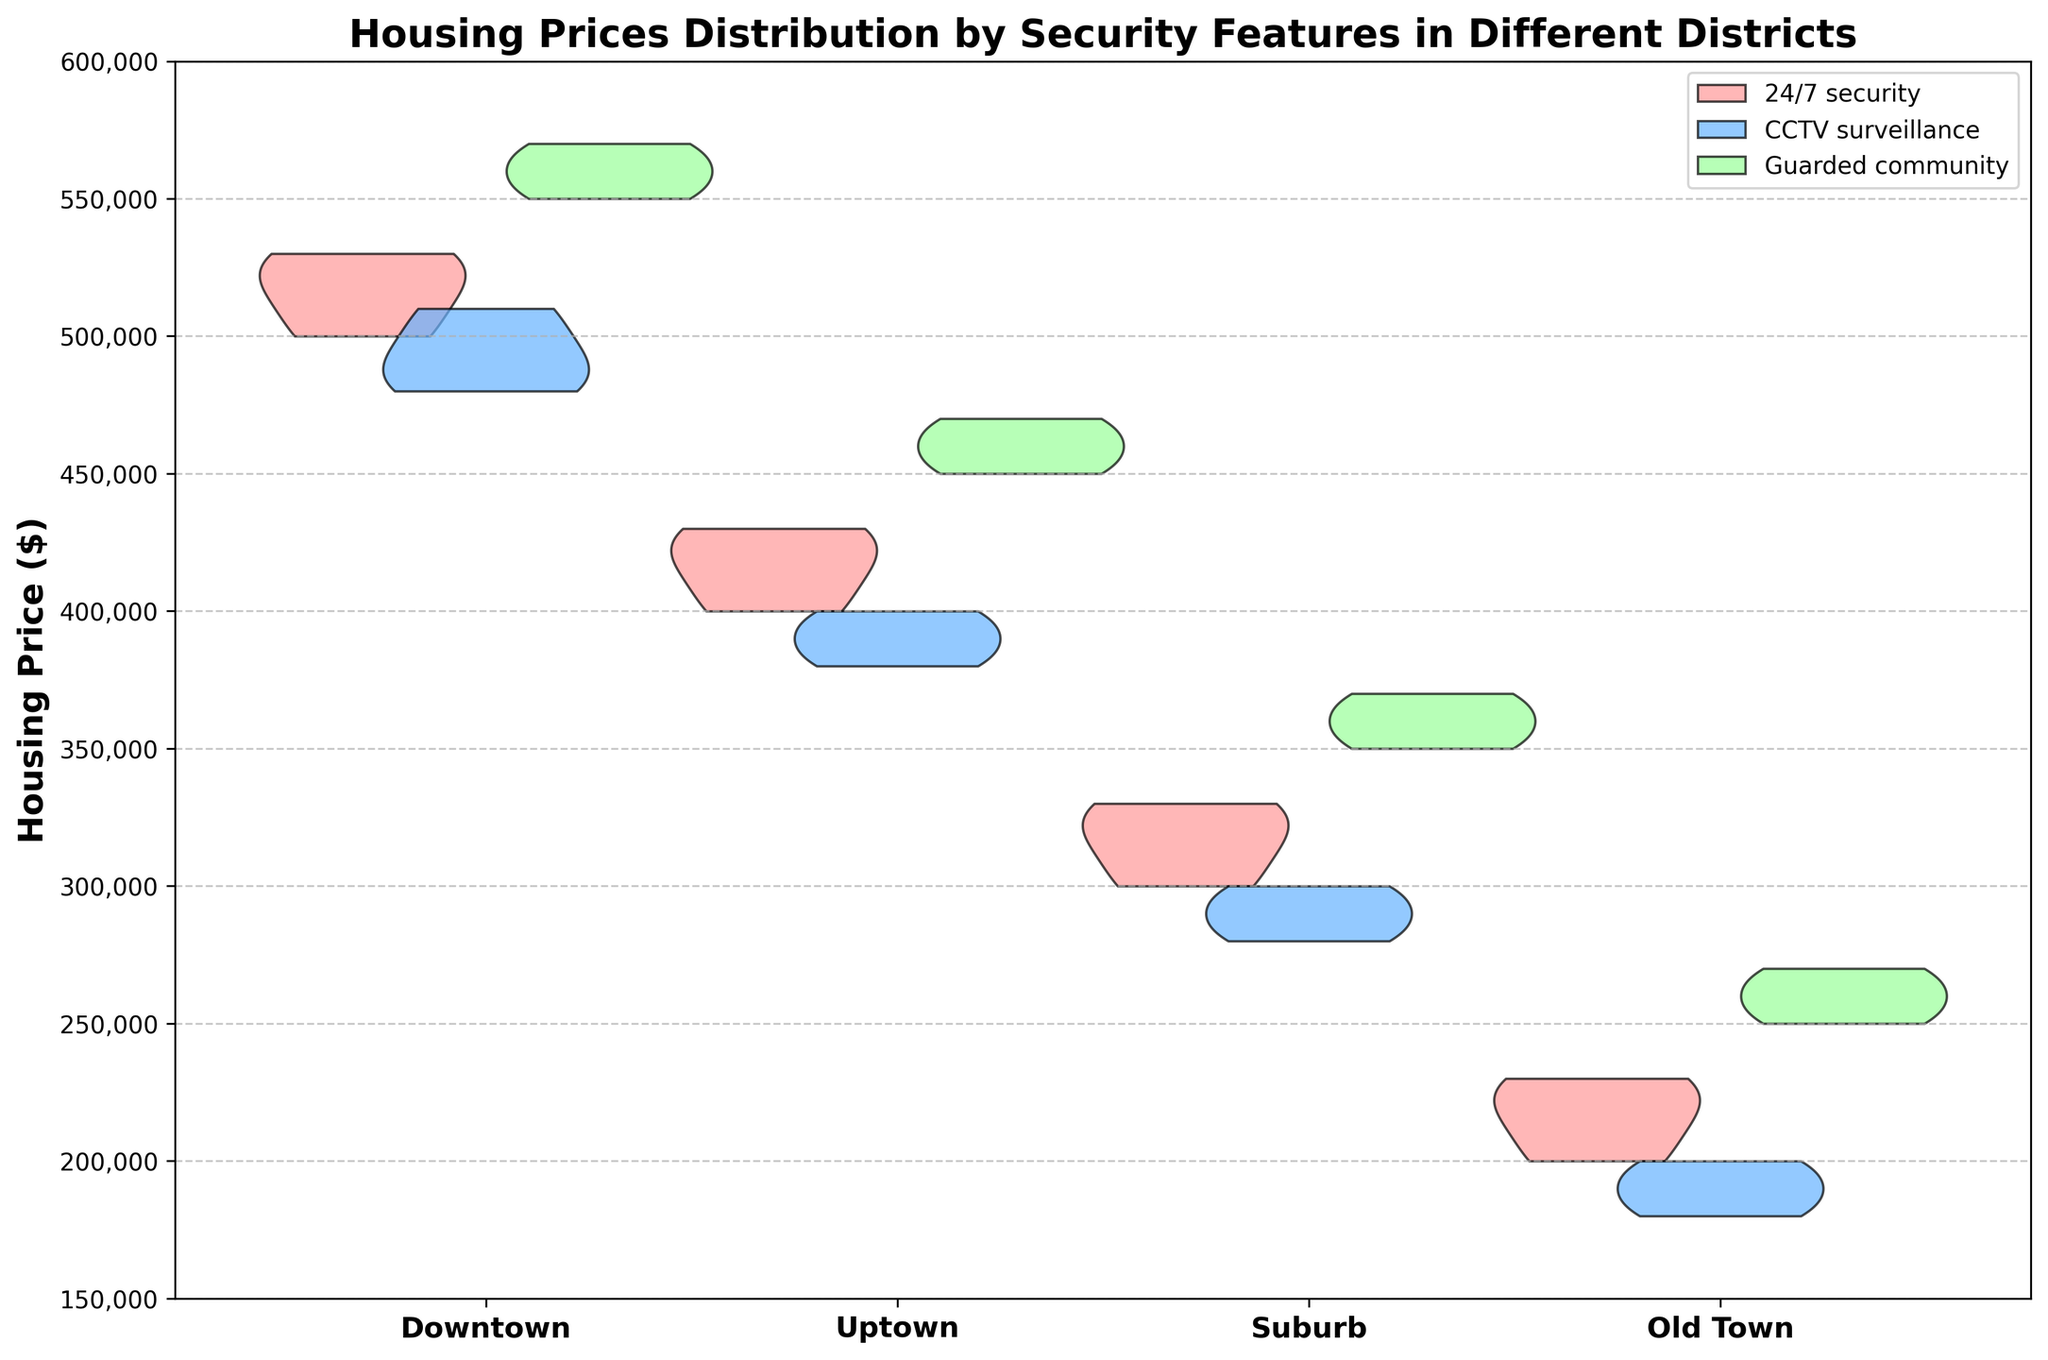How are the housing prices distributed in Downtown? To see the distribution of housing prices in Downtown, look at the width and shape of the violins for Downtown in different security features. The distribution for "Guarded community" is the widest and most spread, indicating a higher range of housing prices, whereas "24/7 security" and "CCTV surveillance" have narrower distributions.
Answer: The distribution ranges from 480,000 to 570,000 with variations depending on security features Which district has the highest median housing price? To determine the highest median housing price, compare the central points of the violins across different districts. The violins with the mean/mode highest placements indicate higher medians. Downtown's "Guarded community" appears to have the highest median point.
Answer: Downtown What is the general trend of housing prices from Old Town to Downtown? Examine the lower end (Old Town) and higher end (Downtown) areas on the violin charts. Notice how the housing prices generally increase as you move from Old Town, Uptown, Suburb, to Downtown.
Answer: Increasing trend Which security feature shows the highest variation in housing prices within any district? Assess the spread (width) of each violin within each district. The security feature with the widest spread indicates the highest variation. "Guarded community" in Downtown displays the widest spread, indicating the highest variation.
Answer: Guarded community in Downtown How does the availability of "24/7 security" impact housing prices in different districts? Observe the violin shapes for "24/7 security" across districts. In Downtown, prices are higher and moderately spread. In Uptown, prices are slightly lower with a moderate spread. In Suburb, prices drop significantly, and in Old Town, prices are lowest but narrow in range.
Answer: Prices decrease from Downtown to Old Town with varying spreads Which district shows the least variation in housing prices for "CCTV surveillance"? Look at the violin widths for "CCTV surveillance" in each district. The district with the narrowest violin indicates the least variation. In Old Town, the "CCTV surveillance" violin is narrower compared to others.
Answer: Old Town Compare the highest housing prices between "24/7 security" and "Guarded community" in Uptown. Evaluate and compare the upper ends of the violins for "24/7 security" and "Guarded community" in Uptown. "Guarded community" shows higher values than "24/7 security" in Uptown.
Answer: Guarded community is higher Are housing prices generally higher or lower in Suburb compared to Old Town for "CCTV surveillance"? Compare the positions of the "CCTV surveillance" violins between Suburb and Old Town. The Suburb shows higher pricing points than Old Town for this security feature.
Answer: Higher in Suburb In which district does "Guarded community" show the highest peak concentration of housing prices? Observe the central peak of the "Guarded community" violin in each district. The sharpest and highest central part indicates the highest concentration. Downtown shows the highest peak concentration.
Answer: Downtown 